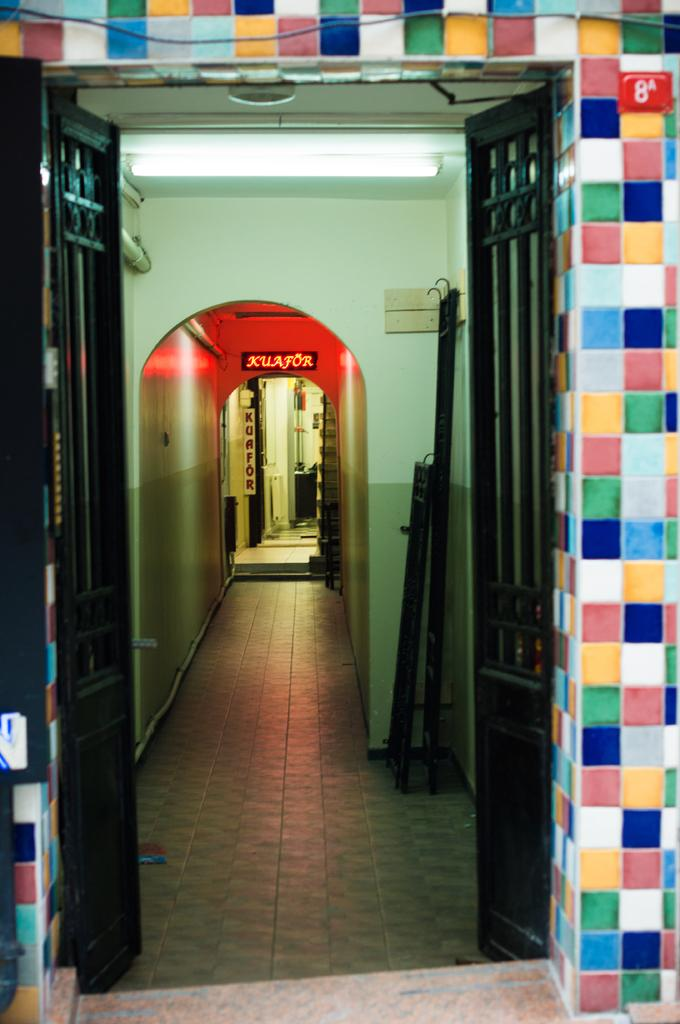What is located in the foreground of the picture? There is a gate in the foreground of the picture. What can be seen in the middle of the picture? There is light and walls in the middle of the picture. What is present in the background of the picture? There are name plates, a door, and walls in the background of the picture. Can you tell me how many letters are visible on the name plates in the image? There is no information about the content of the name plates, so it is impossible to determine how many letters are visible. What type of fire can be seen in the background of the image? There is no fire present in the image. 